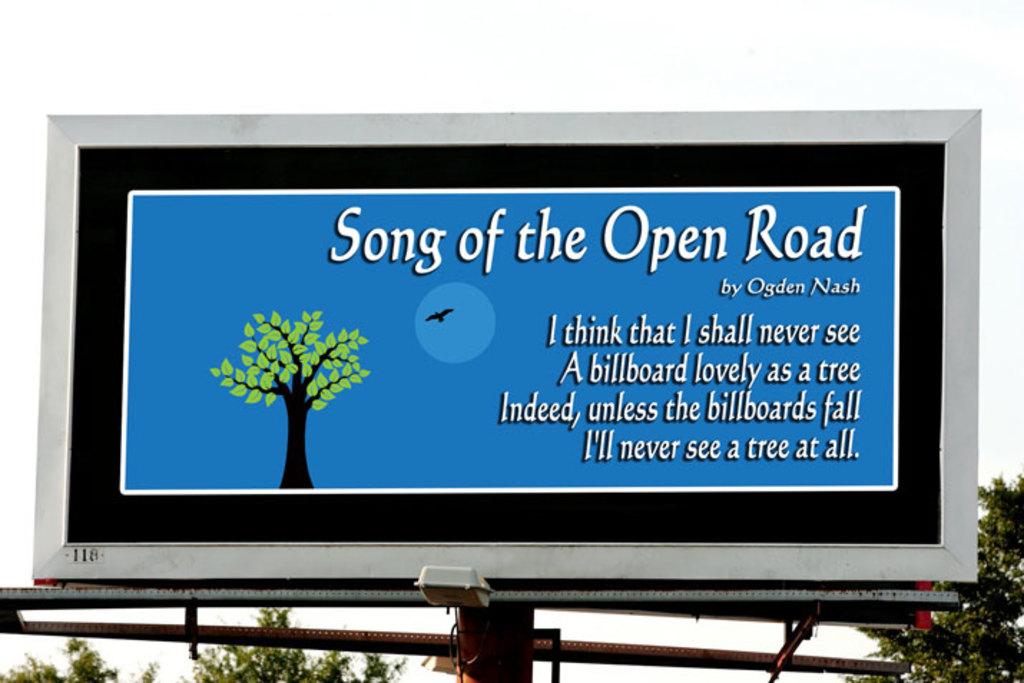Who was the author of the saying on this billboard?
Offer a very short reply. Ogden nash. What is the last word on this billboard?
Provide a short and direct response. All. 